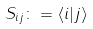Convert formula to latex. <formula><loc_0><loc_0><loc_500><loc_500>S _ { i j } \colon = \langle i | j \rangle</formula> 